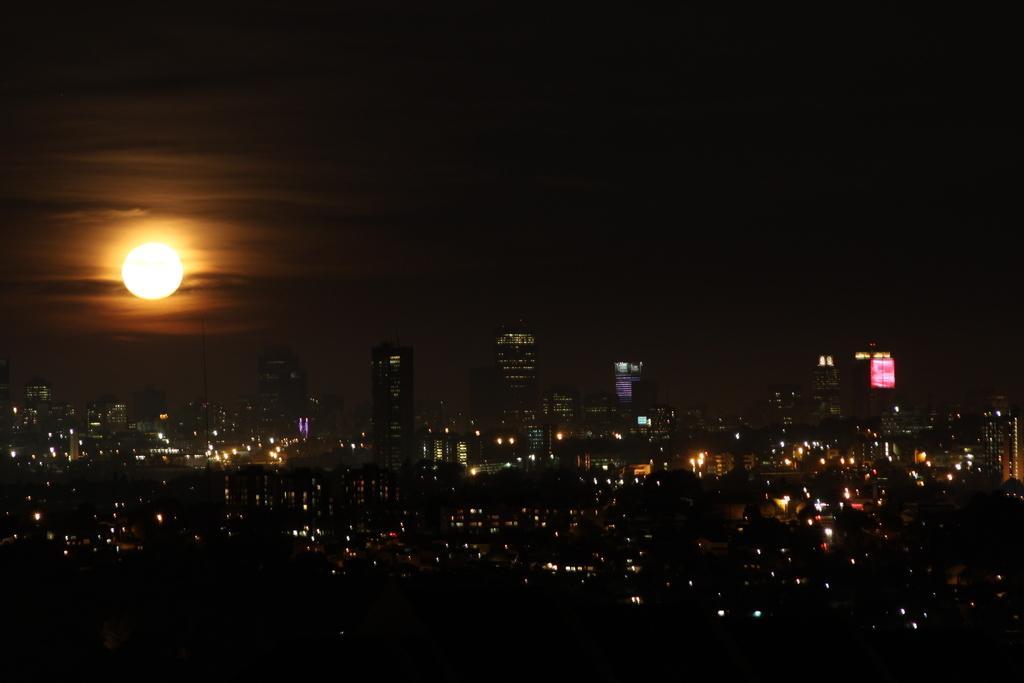Please provide a concise description of this image. In this image we can see some buildings lights and at the top of the image there is moon and dark color sky. 